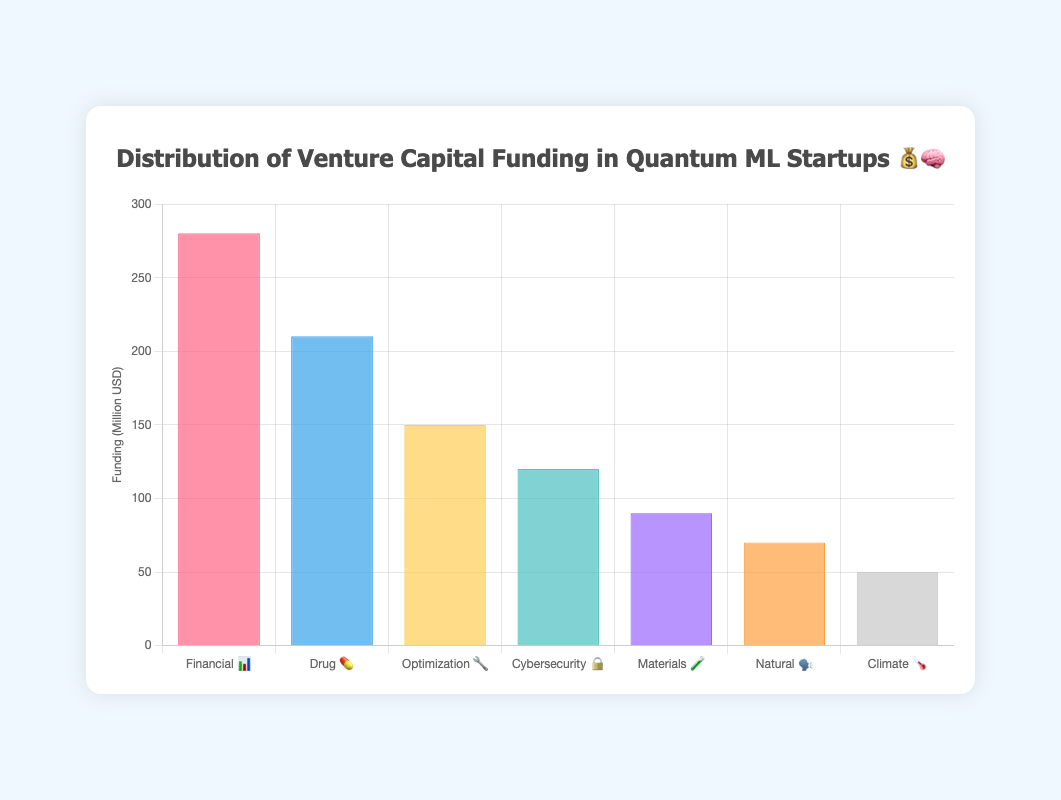Which application area received the highest venture capital funding? The highest bar represents the application with the most funding. Financial Modeling 📊 has the tallest bar, indicating it received the most funding.
Answer: Financial Modeling 📊 What is the total venture capital funding received by Drug Discovery 💊 and Cybersecurity 🔒 combined? Add the funding amounts for Drug Discovery 💊 (210 million USD) and Cybersecurity 🔒 (120 million USD). 210 + 120 = 330 million USD.
Answer: 330 million USD How much more funding did Financial Modeling 📊 receive compared to Natural Language Processing 🗣️? Subtract the funding for Natural Language Processing 🗣️ (70 million USD) from Financial Modeling 📊 (280 million USD). 280 - 70 = 210 million USD.
Answer: 210 million USD Which application area received the least funding? The shortest bar represents the application with the least funding. Climate Modeling 🌡️ has the shortest bar, indicating it received the least funding.
Answer: Climate Modeling 🌡️ Is the funding for Optimization Algorithms 🔧 greater than the combined funding for Materials Science 🧪 and Natural Language Processing 🗣️? Compare the funding for Optimization Algorithms 🔧 (150 million USD) to the sum of Materials Science 🧪 (90 million USD) and Natural Language Processing 🗣️ (70 million USD). 90 + 70 = 160 million USD. 150 < 160, so not greater.
Answer: No How much funding did the bottom three applications receive in total? Add the funding amounts for the three applications: Cybersecurity 🔒 (120 million USD), Materials Science 🧪 (90 million USD), and Climate Modeling 🌡️ (50 million USD). 120 + 90 + 50 = 260 million USD.
Answer: 260 million USD Rank the application areas by their funding from highest to lowest. List the application areas based on the height of the bars from tallest to shortest: Financial Modeling 📊 (280), Drug Discovery 💊 (210), Optimization Algorithms 🔧 (150), Cybersecurity 🔒 (120), Materials Science 🧪 (90), Natural Language Processing 🗣️ (70), Climate Modeling 🌡️ (50).
Answer: Financial Modeling 📊, Drug Discovery 💊, Optimization Algorithms 🔧, Cybersecurity 🔒, Materials Science 🧪, Natural Language Processing 🗣️, Climate Modeling 🌡️ What's the average funding across all application areas? Sum the funding amounts for all applications and divide by the number of applications. (280 + 210 + 150 + 120 + 90 + 70 + 50) / 7 = 970 / 7 ≈ 138.57 million USD.
Answer: Approximately 138.57 million USD 